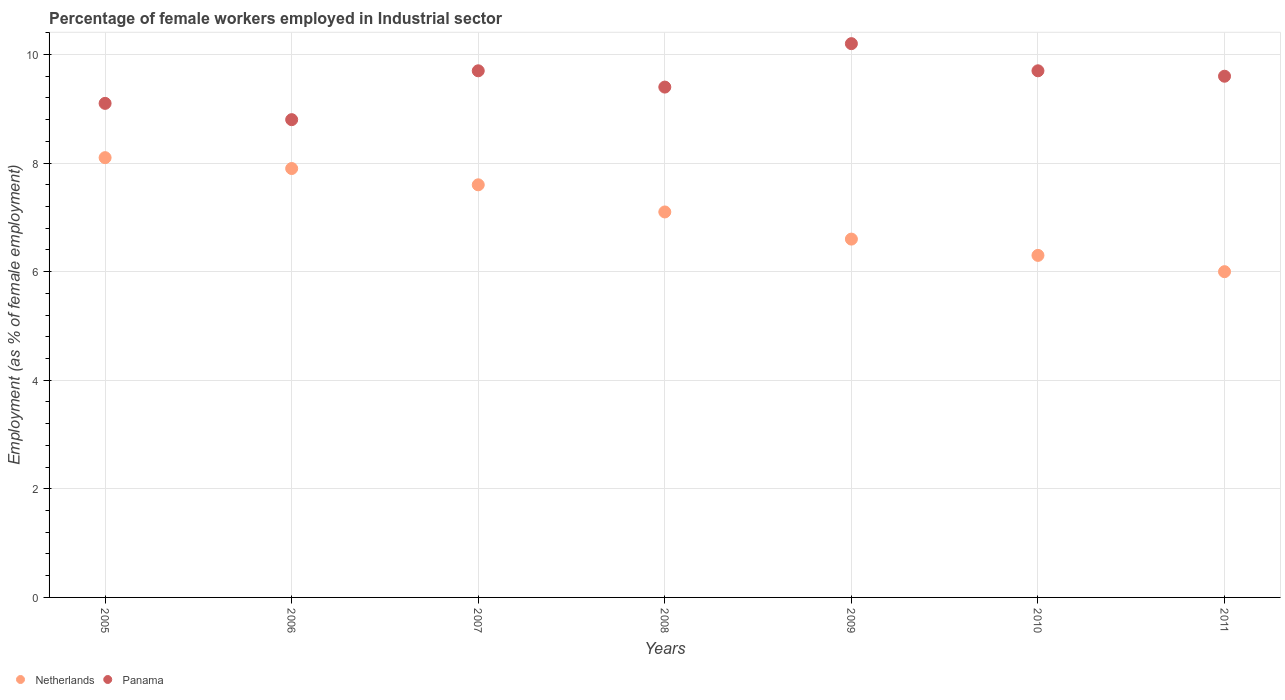How many different coloured dotlines are there?
Your response must be concise. 2. What is the percentage of females employed in Industrial sector in Netherlands in 2009?
Provide a succinct answer. 6.6. Across all years, what is the maximum percentage of females employed in Industrial sector in Panama?
Offer a terse response. 10.2. Across all years, what is the minimum percentage of females employed in Industrial sector in Netherlands?
Give a very brief answer. 6. In which year was the percentage of females employed in Industrial sector in Panama maximum?
Your answer should be compact. 2009. What is the total percentage of females employed in Industrial sector in Netherlands in the graph?
Your answer should be very brief. 49.6. What is the difference between the percentage of females employed in Industrial sector in Netherlands in 2008 and that in 2011?
Provide a short and direct response. 1.1. What is the difference between the percentage of females employed in Industrial sector in Netherlands in 2006 and the percentage of females employed in Industrial sector in Panama in 2009?
Give a very brief answer. -2.3. What is the average percentage of females employed in Industrial sector in Netherlands per year?
Provide a short and direct response. 7.09. In the year 2007, what is the difference between the percentage of females employed in Industrial sector in Netherlands and percentage of females employed in Industrial sector in Panama?
Ensure brevity in your answer.  -2.1. In how many years, is the percentage of females employed in Industrial sector in Netherlands greater than 6 %?
Your answer should be very brief. 6. What is the ratio of the percentage of females employed in Industrial sector in Panama in 2007 to that in 2010?
Keep it short and to the point. 1. What is the difference between the highest and the second highest percentage of females employed in Industrial sector in Netherlands?
Offer a very short reply. 0.2. What is the difference between the highest and the lowest percentage of females employed in Industrial sector in Netherlands?
Give a very brief answer. 2.1. In how many years, is the percentage of females employed in Industrial sector in Panama greater than the average percentage of females employed in Industrial sector in Panama taken over all years?
Your answer should be very brief. 4. How many dotlines are there?
Keep it short and to the point. 2. How many years are there in the graph?
Provide a short and direct response. 7. Does the graph contain any zero values?
Your response must be concise. No. How many legend labels are there?
Provide a short and direct response. 2. What is the title of the graph?
Your answer should be compact. Percentage of female workers employed in Industrial sector. Does "France" appear as one of the legend labels in the graph?
Make the answer very short. No. What is the label or title of the Y-axis?
Your answer should be compact. Employment (as % of female employment). What is the Employment (as % of female employment) of Netherlands in 2005?
Make the answer very short. 8.1. What is the Employment (as % of female employment) in Panama in 2005?
Ensure brevity in your answer.  9.1. What is the Employment (as % of female employment) in Netherlands in 2006?
Your response must be concise. 7.9. What is the Employment (as % of female employment) of Panama in 2006?
Provide a succinct answer. 8.8. What is the Employment (as % of female employment) of Netherlands in 2007?
Your response must be concise. 7.6. What is the Employment (as % of female employment) in Panama in 2007?
Your answer should be very brief. 9.7. What is the Employment (as % of female employment) of Netherlands in 2008?
Your answer should be compact. 7.1. What is the Employment (as % of female employment) in Panama in 2008?
Your answer should be compact. 9.4. What is the Employment (as % of female employment) of Netherlands in 2009?
Ensure brevity in your answer.  6.6. What is the Employment (as % of female employment) in Panama in 2009?
Make the answer very short. 10.2. What is the Employment (as % of female employment) in Netherlands in 2010?
Your answer should be very brief. 6.3. What is the Employment (as % of female employment) of Panama in 2010?
Provide a short and direct response. 9.7. What is the Employment (as % of female employment) of Panama in 2011?
Provide a short and direct response. 9.6. Across all years, what is the maximum Employment (as % of female employment) of Netherlands?
Provide a succinct answer. 8.1. Across all years, what is the maximum Employment (as % of female employment) in Panama?
Your response must be concise. 10.2. Across all years, what is the minimum Employment (as % of female employment) in Netherlands?
Your response must be concise. 6. Across all years, what is the minimum Employment (as % of female employment) of Panama?
Give a very brief answer. 8.8. What is the total Employment (as % of female employment) in Netherlands in the graph?
Make the answer very short. 49.6. What is the total Employment (as % of female employment) of Panama in the graph?
Ensure brevity in your answer.  66.5. What is the difference between the Employment (as % of female employment) in Panama in 2005 and that in 2009?
Provide a short and direct response. -1.1. What is the difference between the Employment (as % of female employment) of Panama in 2005 and that in 2010?
Provide a succinct answer. -0.6. What is the difference between the Employment (as % of female employment) in Netherlands in 2005 and that in 2011?
Offer a terse response. 2.1. What is the difference between the Employment (as % of female employment) in Panama in 2005 and that in 2011?
Provide a succinct answer. -0.5. What is the difference between the Employment (as % of female employment) of Panama in 2006 and that in 2008?
Give a very brief answer. -0.6. What is the difference between the Employment (as % of female employment) of Panama in 2006 and that in 2009?
Offer a very short reply. -1.4. What is the difference between the Employment (as % of female employment) of Panama in 2006 and that in 2010?
Your answer should be compact. -0.9. What is the difference between the Employment (as % of female employment) in Netherlands in 2006 and that in 2011?
Your answer should be very brief. 1.9. What is the difference between the Employment (as % of female employment) of Panama in 2006 and that in 2011?
Your answer should be very brief. -0.8. What is the difference between the Employment (as % of female employment) of Netherlands in 2007 and that in 2008?
Your answer should be compact. 0.5. What is the difference between the Employment (as % of female employment) in Netherlands in 2007 and that in 2010?
Offer a terse response. 1.3. What is the difference between the Employment (as % of female employment) of Panama in 2007 and that in 2011?
Your answer should be very brief. 0.1. What is the difference between the Employment (as % of female employment) in Netherlands in 2008 and that in 2009?
Offer a terse response. 0.5. What is the difference between the Employment (as % of female employment) of Netherlands in 2008 and that in 2011?
Your answer should be very brief. 1.1. What is the difference between the Employment (as % of female employment) in Panama in 2008 and that in 2011?
Give a very brief answer. -0.2. What is the difference between the Employment (as % of female employment) in Netherlands in 2009 and that in 2010?
Provide a short and direct response. 0.3. What is the difference between the Employment (as % of female employment) of Panama in 2009 and that in 2011?
Make the answer very short. 0.6. What is the difference between the Employment (as % of female employment) of Netherlands in 2010 and that in 2011?
Offer a very short reply. 0.3. What is the difference between the Employment (as % of female employment) of Panama in 2010 and that in 2011?
Make the answer very short. 0.1. What is the difference between the Employment (as % of female employment) in Netherlands in 2005 and the Employment (as % of female employment) in Panama in 2006?
Provide a short and direct response. -0.7. What is the difference between the Employment (as % of female employment) of Netherlands in 2005 and the Employment (as % of female employment) of Panama in 2007?
Your answer should be compact. -1.6. What is the difference between the Employment (as % of female employment) in Netherlands in 2005 and the Employment (as % of female employment) in Panama in 2008?
Keep it short and to the point. -1.3. What is the difference between the Employment (as % of female employment) in Netherlands in 2005 and the Employment (as % of female employment) in Panama in 2010?
Keep it short and to the point. -1.6. What is the difference between the Employment (as % of female employment) of Netherlands in 2006 and the Employment (as % of female employment) of Panama in 2009?
Give a very brief answer. -2.3. What is the difference between the Employment (as % of female employment) of Netherlands in 2006 and the Employment (as % of female employment) of Panama in 2011?
Your answer should be very brief. -1.7. What is the difference between the Employment (as % of female employment) of Netherlands in 2007 and the Employment (as % of female employment) of Panama in 2010?
Your answer should be compact. -2.1. What is the difference between the Employment (as % of female employment) in Netherlands in 2008 and the Employment (as % of female employment) in Panama in 2009?
Your response must be concise. -3.1. What is the difference between the Employment (as % of female employment) of Netherlands in 2008 and the Employment (as % of female employment) of Panama in 2011?
Your response must be concise. -2.5. What is the difference between the Employment (as % of female employment) in Netherlands in 2009 and the Employment (as % of female employment) in Panama in 2011?
Your answer should be very brief. -3. What is the difference between the Employment (as % of female employment) of Netherlands in 2010 and the Employment (as % of female employment) of Panama in 2011?
Your answer should be very brief. -3.3. What is the average Employment (as % of female employment) of Netherlands per year?
Provide a succinct answer. 7.09. In the year 2005, what is the difference between the Employment (as % of female employment) in Netherlands and Employment (as % of female employment) in Panama?
Your response must be concise. -1. In the year 2006, what is the difference between the Employment (as % of female employment) of Netherlands and Employment (as % of female employment) of Panama?
Keep it short and to the point. -0.9. In the year 2008, what is the difference between the Employment (as % of female employment) of Netherlands and Employment (as % of female employment) of Panama?
Offer a terse response. -2.3. What is the ratio of the Employment (as % of female employment) of Netherlands in 2005 to that in 2006?
Your response must be concise. 1.03. What is the ratio of the Employment (as % of female employment) in Panama in 2005 to that in 2006?
Keep it short and to the point. 1.03. What is the ratio of the Employment (as % of female employment) of Netherlands in 2005 to that in 2007?
Provide a short and direct response. 1.07. What is the ratio of the Employment (as % of female employment) in Panama in 2005 to that in 2007?
Make the answer very short. 0.94. What is the ratio of the Employment (as % of female employment) of Netherlands in 2005 to that in 2008?
Give a very brief answer. 1.14. What is the ratio of the Employment (as % of female employment) of Panama in 2005 to that in 2008?
Your answer should be very brief. 0.97. What is the ratio of the Employment (as % of female employment) of Netherlands in 2005 to that in 2009?
Offer a very short reply. 1.23. What is the ratio of the Employment (as % of female employment) of Panama in 2005 to that in 2009?
Your answer should be very brief. 0.89. What is the ratio of the Employment (as % of female employment) in Netherlands in 2005 to that in 2010?
Keep it short and to the point. 1.29. What is the ratio of the Employment (as % of female employment) in Panama in 2005 to that in 2010?
Provide a short and direct response. 0.94. What is the ratio of the Employment (as % of female employment) of Netherlands in 2005 to that in 2011?
Offer a terse response. 1.35. What is the ratio of the Employment (as % of female employment) in Panama in 2005 to that in 2011?
Give a very brief answer. 0.95. What is the ratio of the Employment (as % of female employment) in Netherlands in 2006 to that in 2007?
Keep it short and to the point. 1.04. What is the ratio of the Employment (as % of female employment) of Panama in 2006 to that in 2007?
Keep it short and to the point. 0.91. What is the ratio of the Employment (as % of female employment) in Netherlands in 2006 to that in 2008?
Offer a terse response. 1.11. What is the ratio of the Employment (as % of female employment) in Panama in 2006 to that in 2008?
Keep it short and to the point. 0.94. What is the ratio of the Employment (as % of female employment) of Netherlands in 2006 to that in 2009?
Give a very brief answer. 1.2. What is the ratio of the Employment (as % of female employment) in Panama in 2006 to that in 2009?
Offer a very short reply. 0.86. What is the ratio of the Employment (as % of female employment) of Netherlands in 2006 to that in 2010?
Your answer should be compact. 1.25. What is the ratio of the Employment (as % of female employment) of Panama in 2006 to that in 2010?
Your response must be concise. 0.91. What is the ratio of the Employment (as % of female employment) of Netherlands in 2006 to that in 2011?
Your answer should be very brief. 1.32. What is the ratio of the Employment (as % of female employment) of Netherlands in 2007 to that in 2008?
Offer a very short reply. 1.07. What is the ratio of the Employment (as % of female employment) of Panama in 2007 to that in 2008?
Your answer should be compact. 1.03. What is the ratio of the Employment (as % of female employment) in Netherlands in 2007 to that in 2009?
Provide a short and direct response. 1.15. What is the ratio of the Employment (as % of female employment) in Panama in 2007 to that in 2009?
Offer a very short reply. 0.95. What is the ratio of the Employment (as % of female employment) of Netherlands in 2007 to that in 2010?
Offer a terse response. 1.21. What is the ratio of the Employment (as % of female employment) in Netherlands in 2007 to that in 2011?
Keep it short and to the point. 1.27. What is the ratio of the Employment (as % of female employment) of Panama in 2007 to that in 2011?
Give a very brief answer. 1.01. What is the ratio of the Employment (as % of female employment) of Netherlands in 2008 to that in 2009?
Your answer should be very brief. 1.08. What is the ratio of the Employment (as % of female employment) in Panama in 2008 to that in 2009?
Provide a short and direct response. 0.92. What is the ratio of the Employment (as % of female employment) of Netherlands in 2008 to that in 2010?
Your answer should be compact. 1.13. What is the ratio of the Employment (as % of female employment) in Panama in 2008 to that in 2010?
Make the answer very short. 0.97. What is the ratio of the Employment (as % of female employment) of Netherlands in 2008 to that in 2011?
Give a very brief answer. 1.18. What is the ratio of the Employment (as % of female employment) in Panama in 2008 to that in 2011?
Your answer should be very brief. 0.98. What is the ratio of the Employment (as % of female employment) of Netherlands in 2009 to that in 2010?
Your answer should be very brief. 1.05. What is the ratio of the Employment (as % of female employment) in Panama in 2009 to that in 2010?
Provide a succinct answer. 1.05. What is the ratio of the Employment (as % of female employment) in Panama in 2009 to that in 2011?
Keep it short and to the point. 1.06. What is the ratio of the Employment (as % of female employment) of Panama in 2010 to that in 2011?
Offer a terse response. 1.01. 